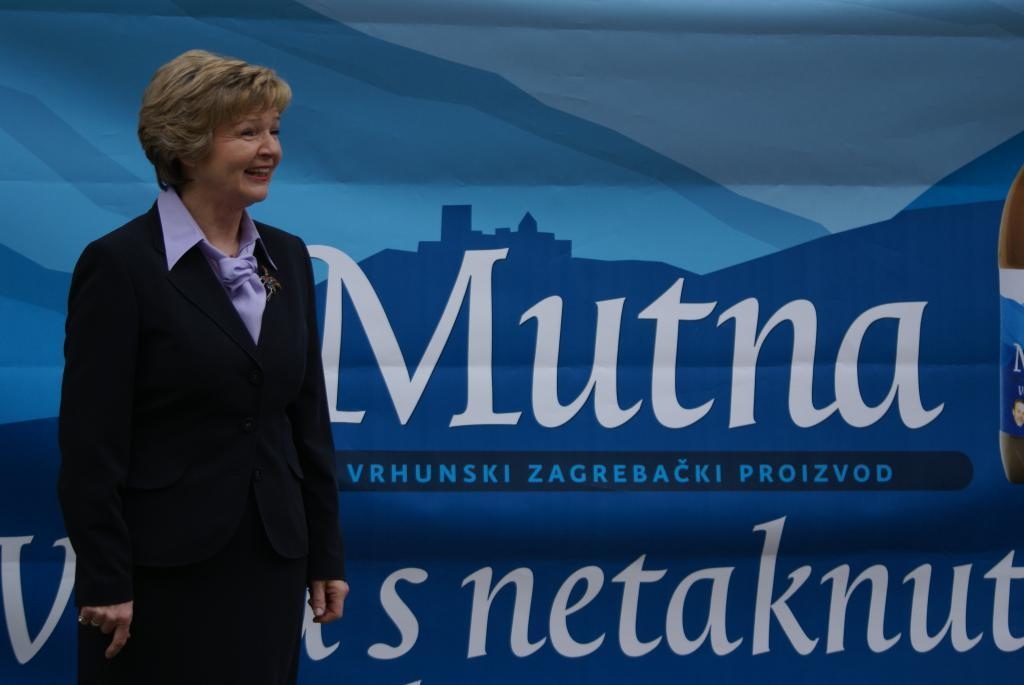Who is the main subject in the image? There is a lady in the image. Where is the lady positioned in the image? The lady is standing on the left side of the image. What can be seen in the background of the image? There is a poster present in the background of the image. What type of offer is the lady making in the image? There is no offer being made in the image; the lady is simply standing on the left side. Can you hear a whistle in the image? There is no whistle present in the image; it is a silent scene. 